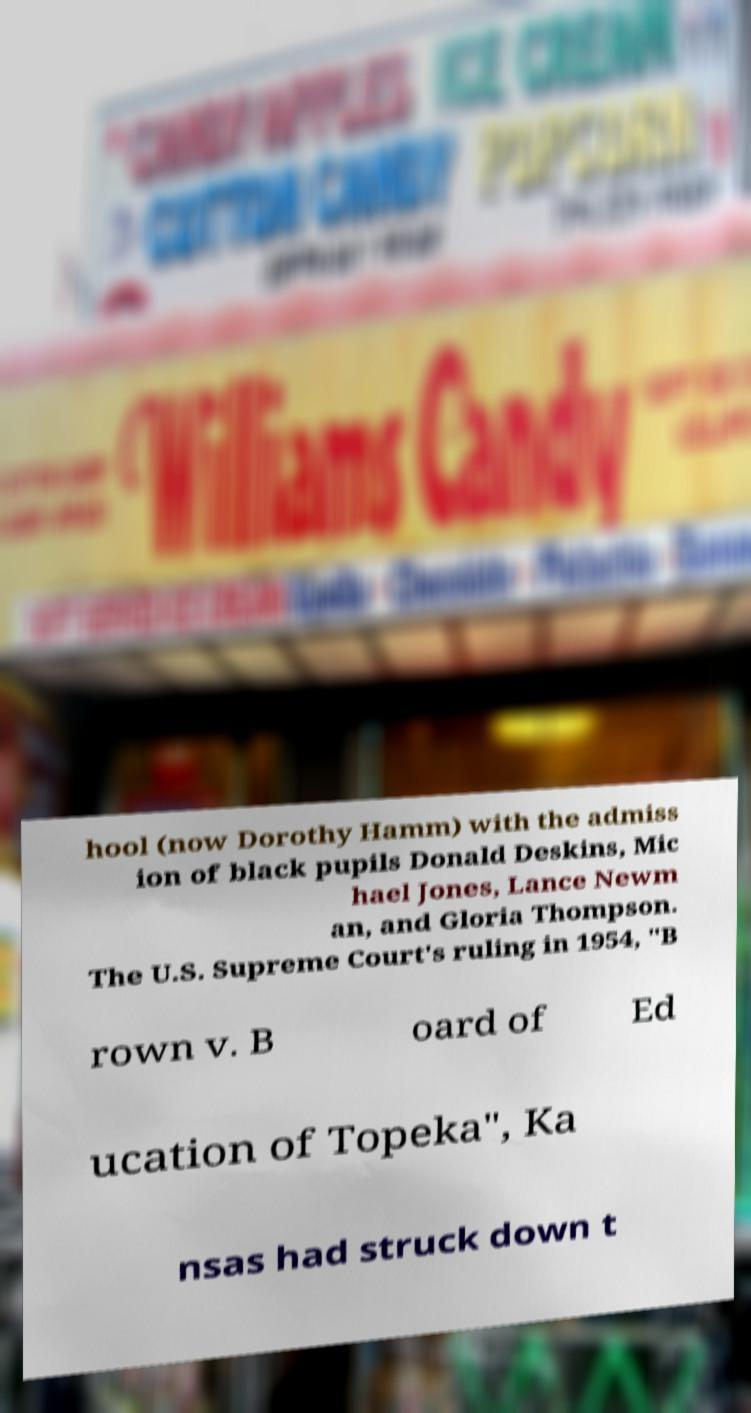Can you accurately transcribe the text from the provided image for me? hool (now Dorothy Hamm) with the admiss ion of black pupils Donald Deskins, Mic hael Jones, Lance Newm an, and Gloria Thompson. The U.S. Supreme Court's ruling in 1954, "B rown v. B oard of Ed ucation of Topeka", Ka nsas had struck down t 